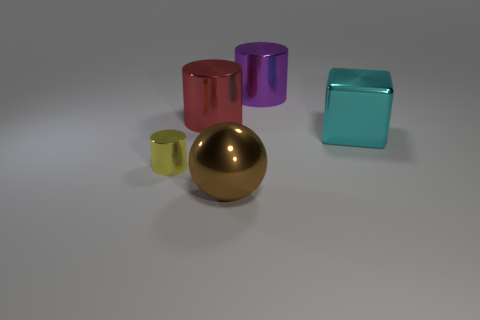Subtract all purple shiny cylinders. How many cylinders are left? 2 Add 1 big gray rubber spheres. How many objects exist? 6 Subtract all red cylinders. How many cylinders are left? 2 Subtract all spheres. How many objects are left? 4 Subtract 1 spheres. How many spheres are left? 0 Subtract all brown cubes. Subtract all green balls. How many cubes are left? 1 Subtract all big cyan metallic balls. Subtract all small yellow cylinders. How many objects are left? 4 Add 3 large purple cylinders. How many large purple cylinders are left? 4 Add 1 large cyan rubber cylinders. How many large cyan rubber cylinders exist? 1 Subtract 0 gray blocks. How many objects are left? 5 